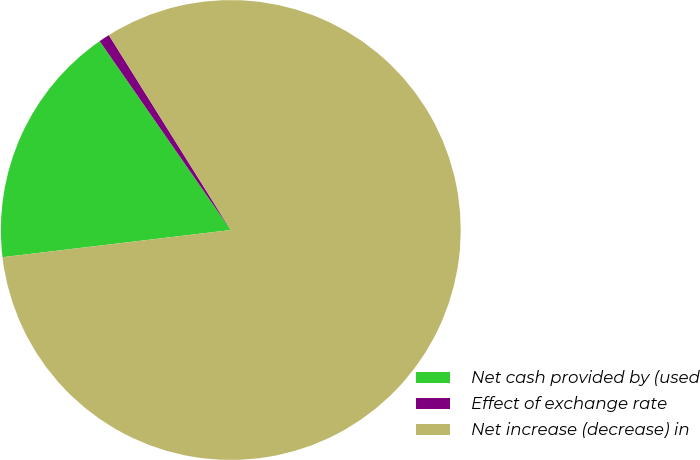Convert chart to OTSL. <chart><loc_0><loc_0><loc_500><loc_500><pie_chart><fcel>Net cash provided by (used<fcel>Effect of exchange rate<fcel>Net increase (decrease) in<nl><fcel>17.23%<fcel>0.76%<fcel>82.01%<nl></chart> 